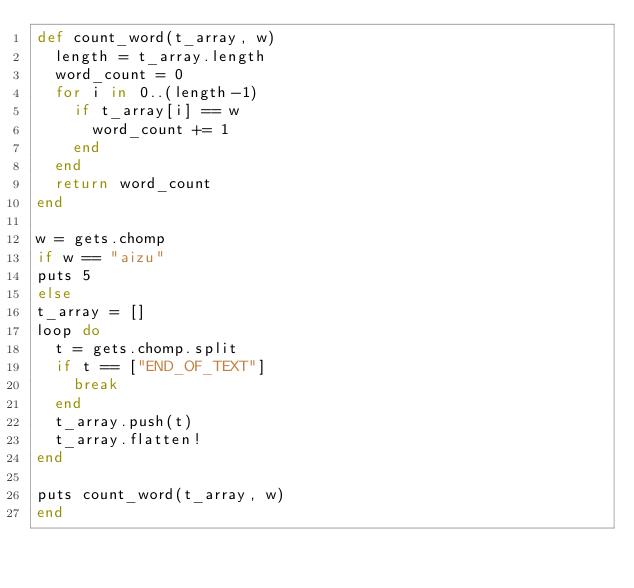Convert code to text. <code><loc_0><loc_0><loc_500><loc_500><_Ruby_>def count_word(t_array, w)
  length = t_array.length
  word_count = 0
  for i in 0..(length-1)
    if t_array[i] == w
      word_count += 1
    end
  end
  return word_count
end

w = gets.chomp
if w == "aizu"
puts 5
else
t_array = []
loop do
  t = gets.chomp.split
  if t == ["END_OF_TEXT"]
    break
  end
  t_array.push(t)
  t_array.flatten!
end

puts count_word(t_array, w)
end</code> 